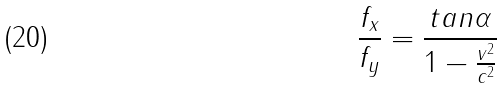Convert formula to latex. <formula><loc_0><loc_0><loc_500><loc_500>\frac { f _ { x } } { f _ { y } } = \frac { t a n \alpha } { 1 - \frac { v ^ { 2 } } { c ^ { 2 } } }</formula> 